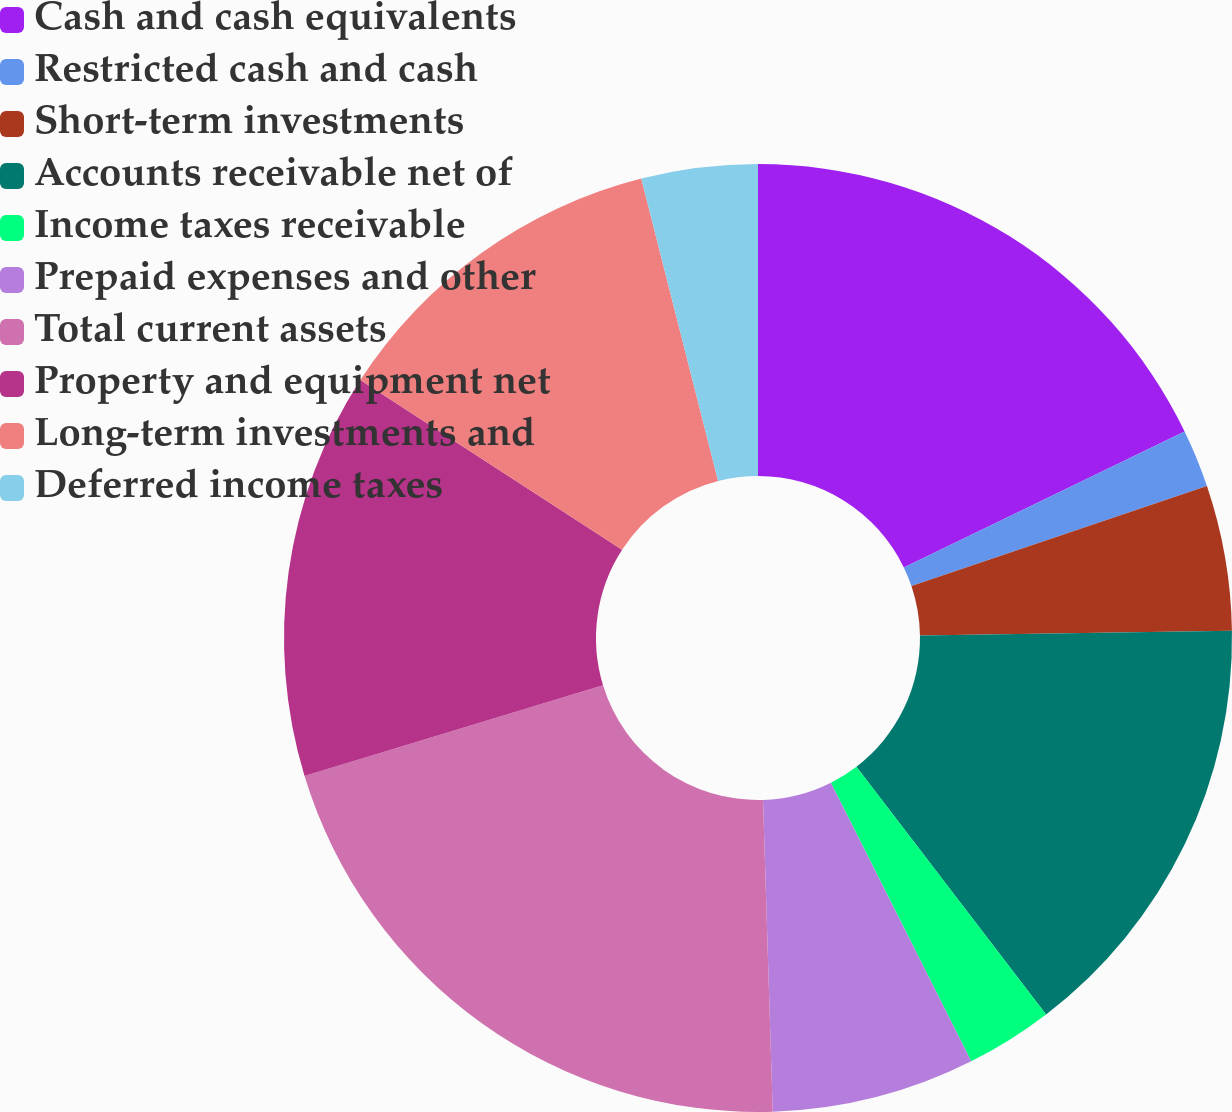<chart> <loc_0><loc_0><loc_500><loc_500><pie_chart><fcel>Cash and cash equivalents<fcel>Restricted cash and cash<fcel>Short-term investments<fcel>Accounts receivable net of<fcel>Income taxes receivable<fcel>Prepaid expenses and other<fcel>Total current assets<fcel>Property and equipment net<fcel>Long-term investments and<fcel>Deferred income taxes<nl><fcel>17.82%<fcel>1.98%<fcel>4.95%<fcel>14.85%<fcel>2.97%<fcel>6.93%<fcel>20.79%<fcel>13.86%<fcel>11.88%<fcel>3.96%<nl></chart> 